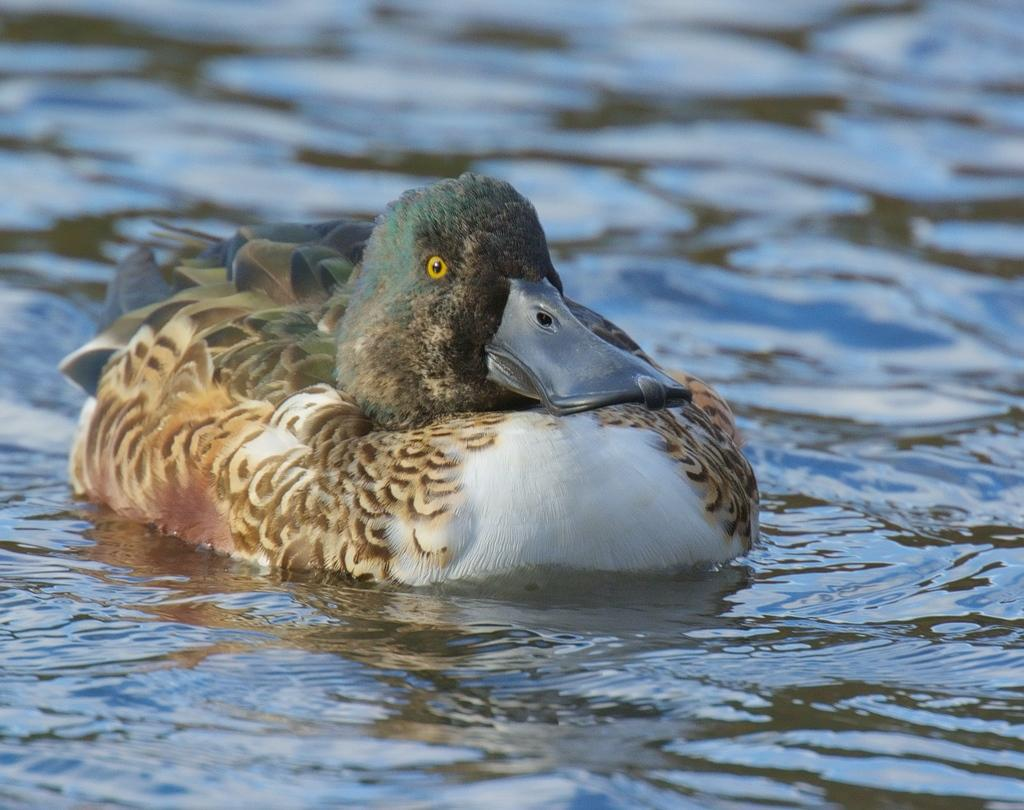What is the primary element visible in the image? There is water in the image. Can you describe the main subject in the image? There is a duck in the center of the image. What type of pest can be seen in the image? There is no pest present in the image; it features a duck in the water. 